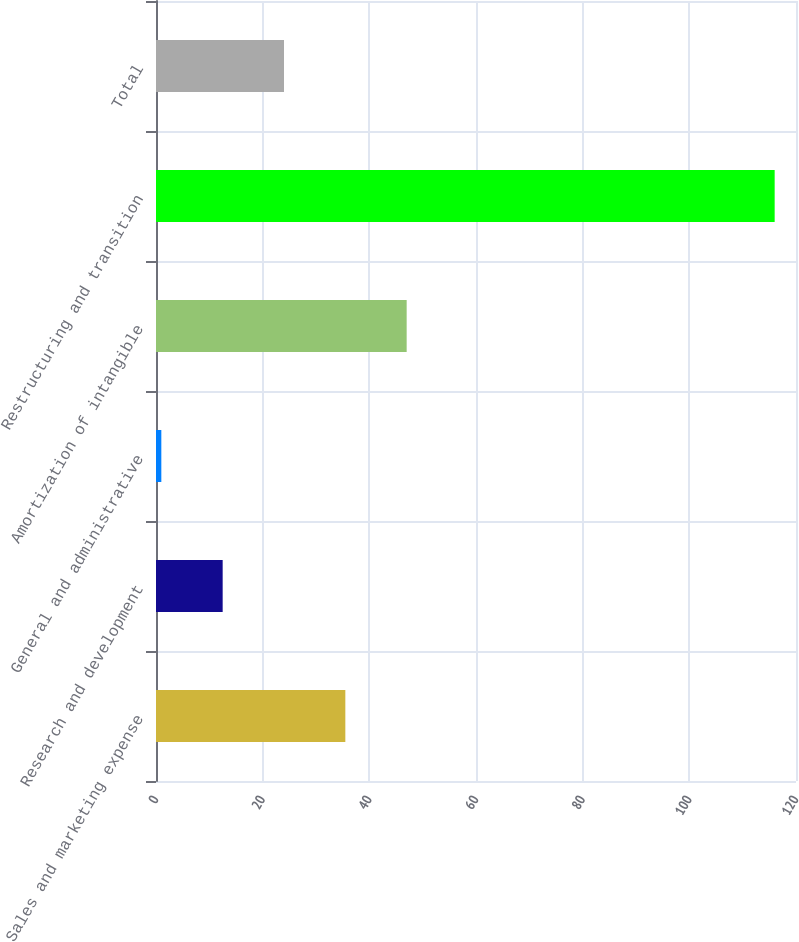Convert chart to OTSL. <chart><loc_0><loc_0><loc_500><loc_500><bar_chart><fcel>Sales and marketing expense<fcel>Research and development<fcel>General and administrative<fcel>Amortization of intangible<fcel>Restructuring and transition<fcel>Total<nl><fcel>35.5<fcel>12.5<fcel>1<fcel>47<fcel>116<fcel>24<nl></chart> 